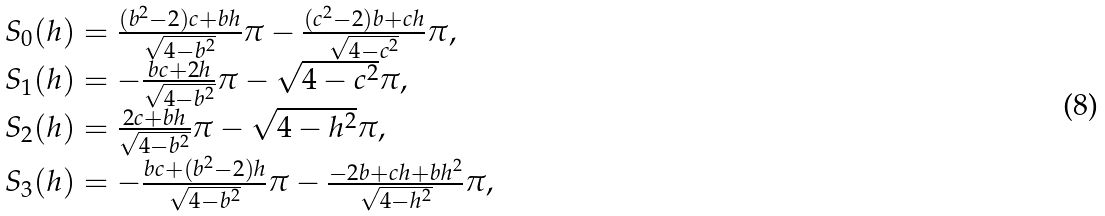Convert formula to latex. <formula><loc_0><loc_0><loc_500><loc_500>\begin{array} { l l } S _ { 0 } ( h ) = \frac { ( b ^ { 2 } - 2 ) c + b h } { \sqrt { 4 - b ^ { 2 } } } \pi - \frac { ( c ^ { 2 } - 2 ) b + c h } { \sqrt { 4 - c ^ { 2 } } } \pi , \\ S _ { 1 } ( h ) = - \frac { b c + 2 h } { \sqrt { 4 - b ^ { 2 } } } \pi - \sqrt { 4 - c ^ { 2 } } \pi , \\ S _ { 2 } ( h ) = \frac { 2 c + b h } { \sqrt { 4 - b ^ { 2 } } } \pi - \sqrt { 4 - h ^ { 2 } } \pi , \\ S _ { 3 } ( h ) = - \frac { b c + ( b ^ { 2 } - 2 ) h } { \sqrt { 4 - b ^ { 2 } } } \pi - \frac { - 2 b + c h + b h ^ { 2 } } { \sqrt { 4 - h ^ { 2 } } } \pi , \end{array}</formula> 